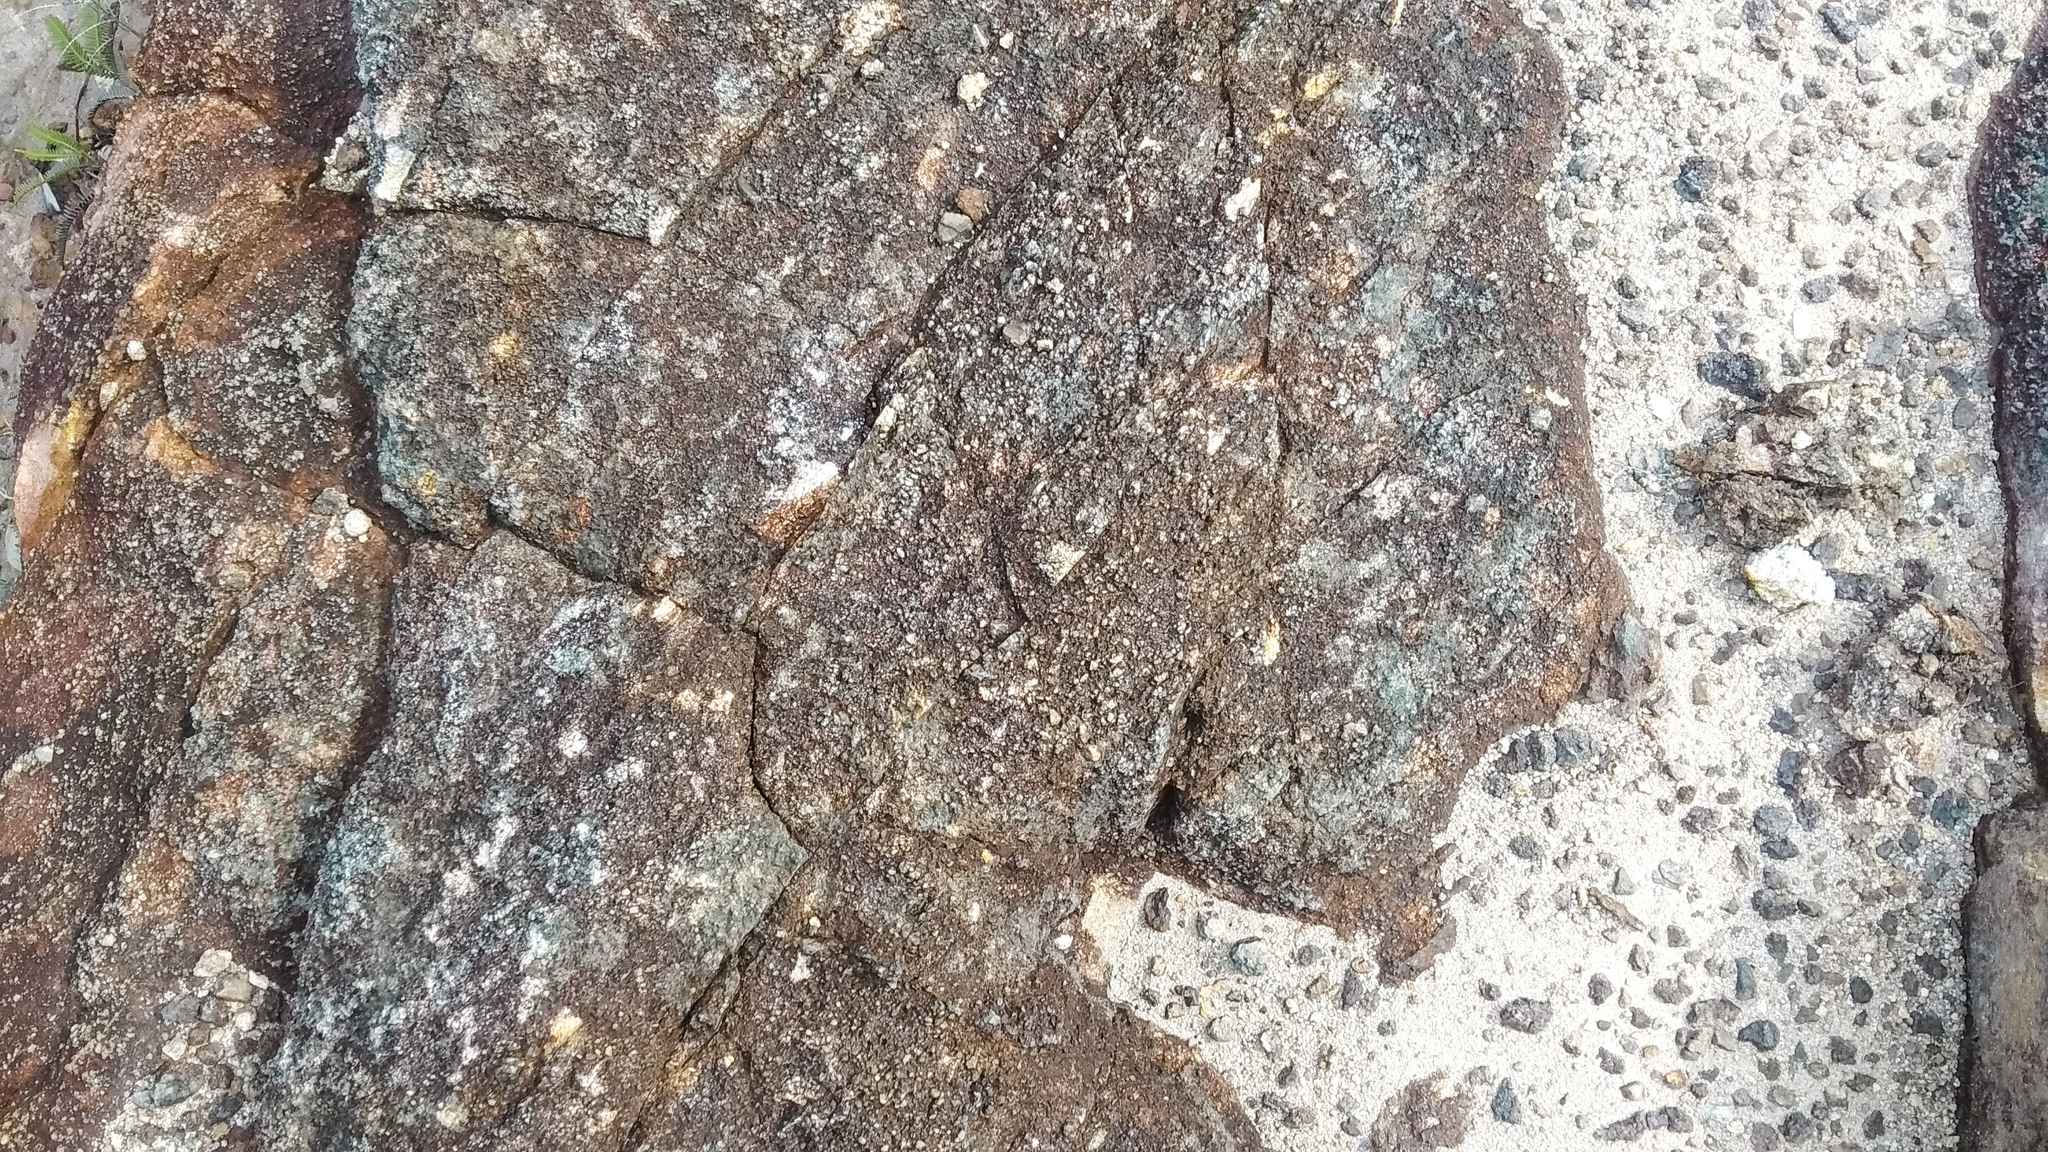What do you think is going on in this snapshot? The image captures a detailed close-up of a weathered stone surface. This surface seems to be part of a larger stone structure or natural rock formation. The stones exhibit various shades of brown, gray, and some patches of green moss, indicating prolonged exposure to natural elements. The rough, irregular surface is interspersed with small, gravel-like particles and sections that appear eroded or cracked. The scene evokes a sense of rugged natural beauty, reflecting the enduring strength and timeless character of the stone, which stands resolute despite the passage of time and the harshness of weather. 